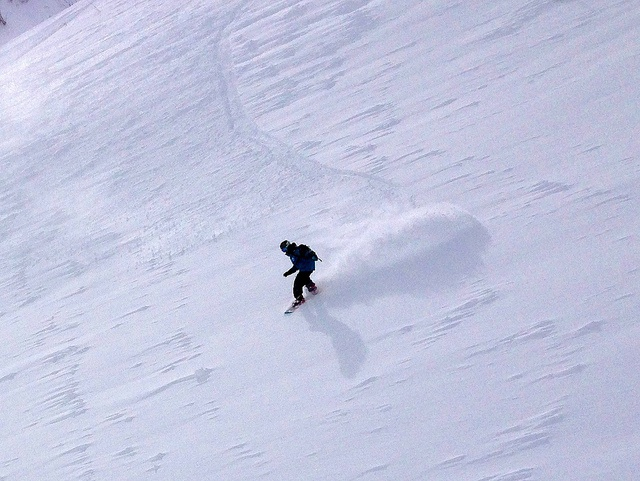Describe the objects in this image and their specific colors. I can see people in darkgray, black, navy, gray, and lightgray tones, snowboard in darkgray and gray tones, backpack in darkgray, black, navy, blue, and gray tones, and skis in darkgray, gray, and lavender tones in this image. 